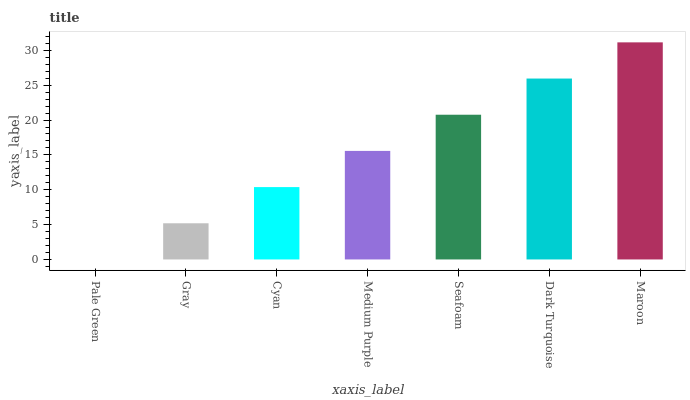Is Pale Green the minimum?
Answer yes or no. Yes. Is Maroon the maximum?
Answer yes or no. Yes. Is Gray the minimum?
Answer yes or no. No. Is Gray the maximum?
Answer yes or no. No. Is Gray greater than Pale Green?
Answer yes or no. Yes. Is Pale Green less than Gray?
Answer yes or no. Yes. Is Pale Green greater than Gray?
Answer yes or no. No. Is Gray less than Pale Green?
Answer yes or no. No. Is Medium Purple the high median?
Answer yes or no. Yes. Is Medium Purple the low median?
Answer yes or no. Yes. Is Dark Turquoise the high median?
Answer yes or no. No. Is Seafoam the low median?
Answer yes or no. No. 